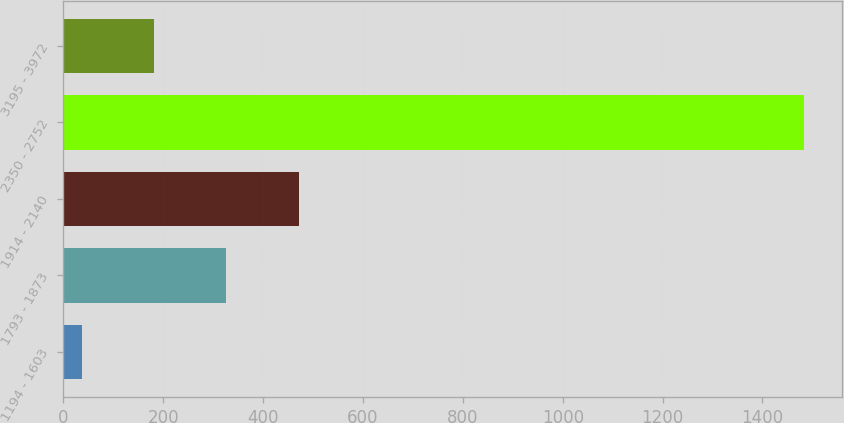Convert chart. <chart><loc_0><loc_0><loc_500><loc_500><bar_chart><fcel>1194 - 1603<fcel>1793 - 1873<fcel>1914 - 2140<fcel>2350 - 2752<fcel>3195 - 3972<nl><fcel>37<fcel>326.4<fcel>471.1<fcel>1484<fcel>181.7<nl></chart> 